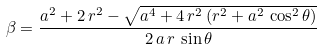<formula> <loc_0><loc_0><loc_500><loc_500>\beta = \frac { a ^ { 2 } + 2 \, r ^ { 2 } - { \sqrt { a ^ { 4 } + 4 \, r ^ { 2 } \, ( r ^ { 2 } + a ^ { 2 } \, \cos ^ { 2 } \theta ) } } } { 2 \, a \, r \, \sin \theta }</formula> 